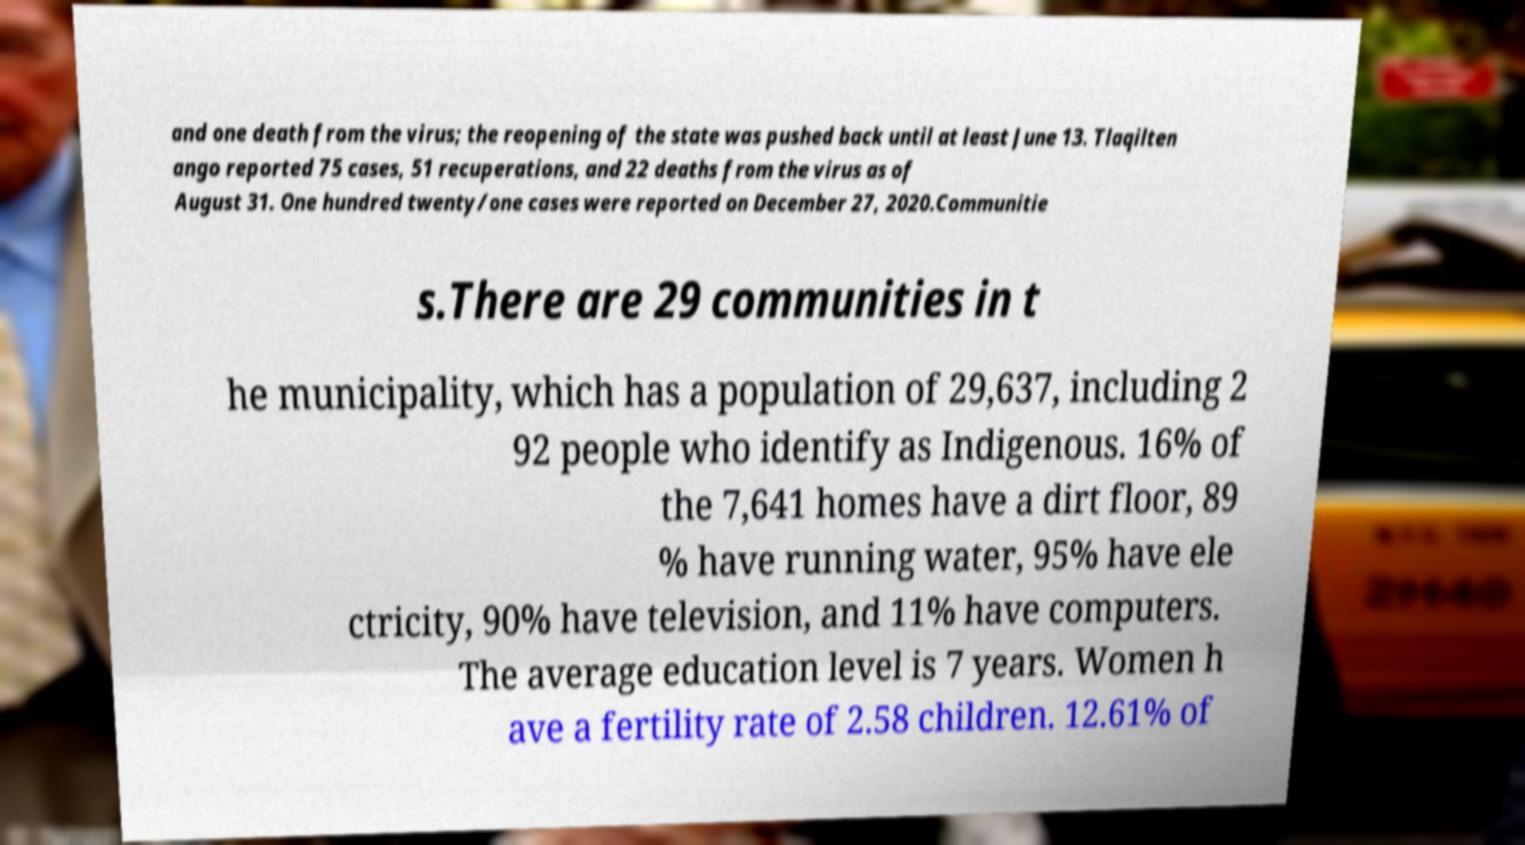Please read and relay the text visible in this image. What does it say? and one death from the virus; the reopening of the state was pushed back until at least June 13. Tlaqilten ango reported 75 cases, 51 recuperations, and 22 deaths from the virus as of August 31. One hundred twenty/one cases were reported on December 27, 2020.Communitie s.There are 29 communities in t he municipality, which has a population of 29,637, including 2 92 people who identify as Indigenous. 16% of the 7,641 homes have a dirt floor, 89 % have running water, 95% have ele ctricity, 90% have television, and 11% have computers. The average education level is 7 years. Women h ave a fertility rate of 2.58 children. 12.61% of 